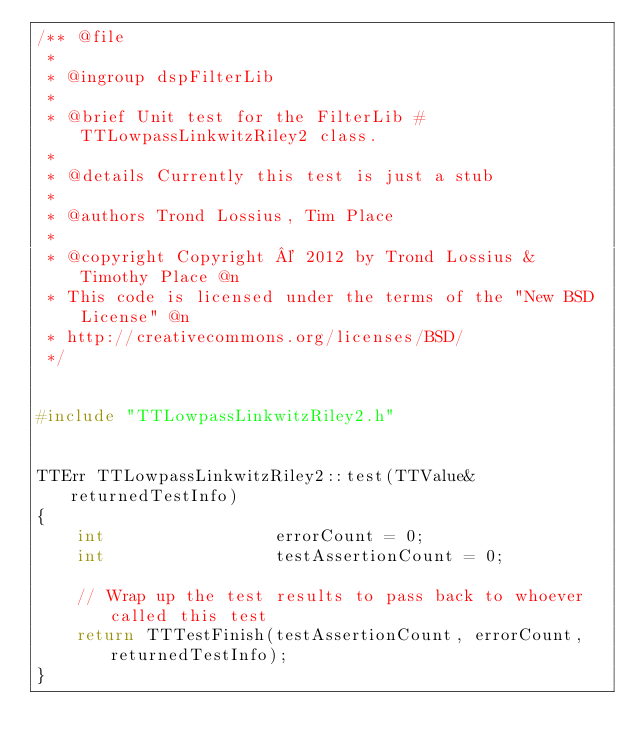Convert code to text. <code><loc_0><loc_0><loc_500><loc_500><_C++_>/** @file
 *
 * @ingroup dspFilterLib
 *
 * @brief Unit test for the FilterLib #TTLowpassLinkwitzRiley2 class.
 *
 * @details Currently this test is just a stub
 *
 * @authors Trond Lossius, Tim Place
 *
 * @copyright Copyright © 2012 by Trond Lossius & Timothy Place @n
 * This code is licensed under the terms of the "New BSD License" @n
 * http://creativecommons.org/licenses/BSD/
 */


#include "TTLowpassLinkwitzRiley2.h"


TTErr TTLowpassLinkwitzRiley2::test(TTValue& returnedTestInfo)
{
	int					errorCount = 0;
	int					testAssertionCount = 0;	
	
	// Wrap up the test results to pass back to whoever called this test
	return TTTestFinish(testAssertionCount, errorCount, returnedTestInfo);
}

</code> 